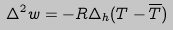<formula> <loc_0><loc_0><loc_500><loc_500>\Delta ^ { 2 } w = - R \Delta _ { h } ( T - \overline { T } )</formula> 